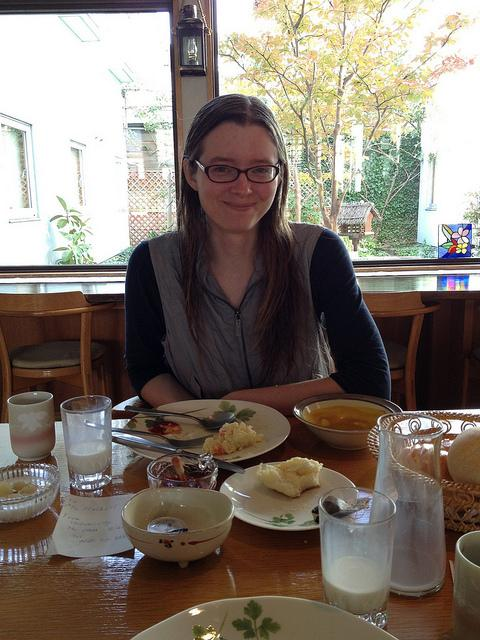How many people are likely enjoying this meal? Please explain your reasoning. two. If you look at the number of glasses and plates there is one set for each person and you can see that there are two. 